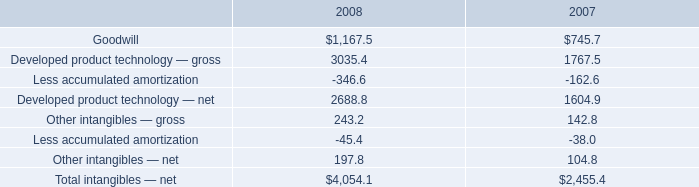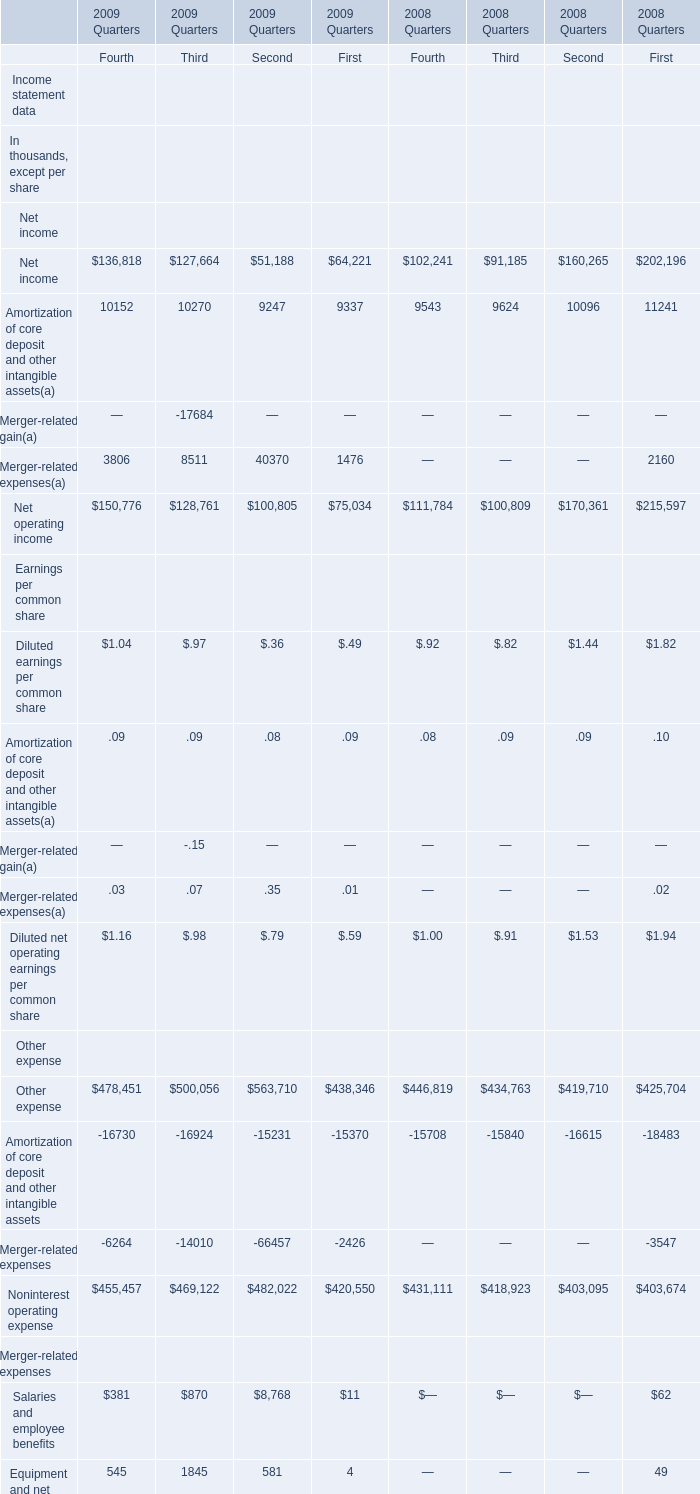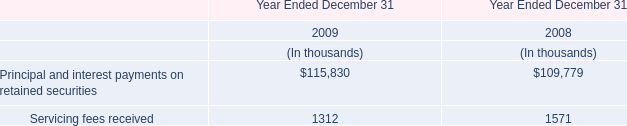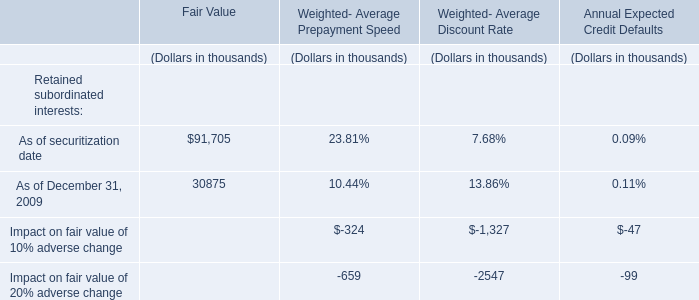What's the average of Goodwill Average common equity of 2008 Quarters Fourth, and Developed product technology — gross of 2008 ? 
Computations: ((3192.0 + 3035.4) / 2)
Answer: 3113.7. 